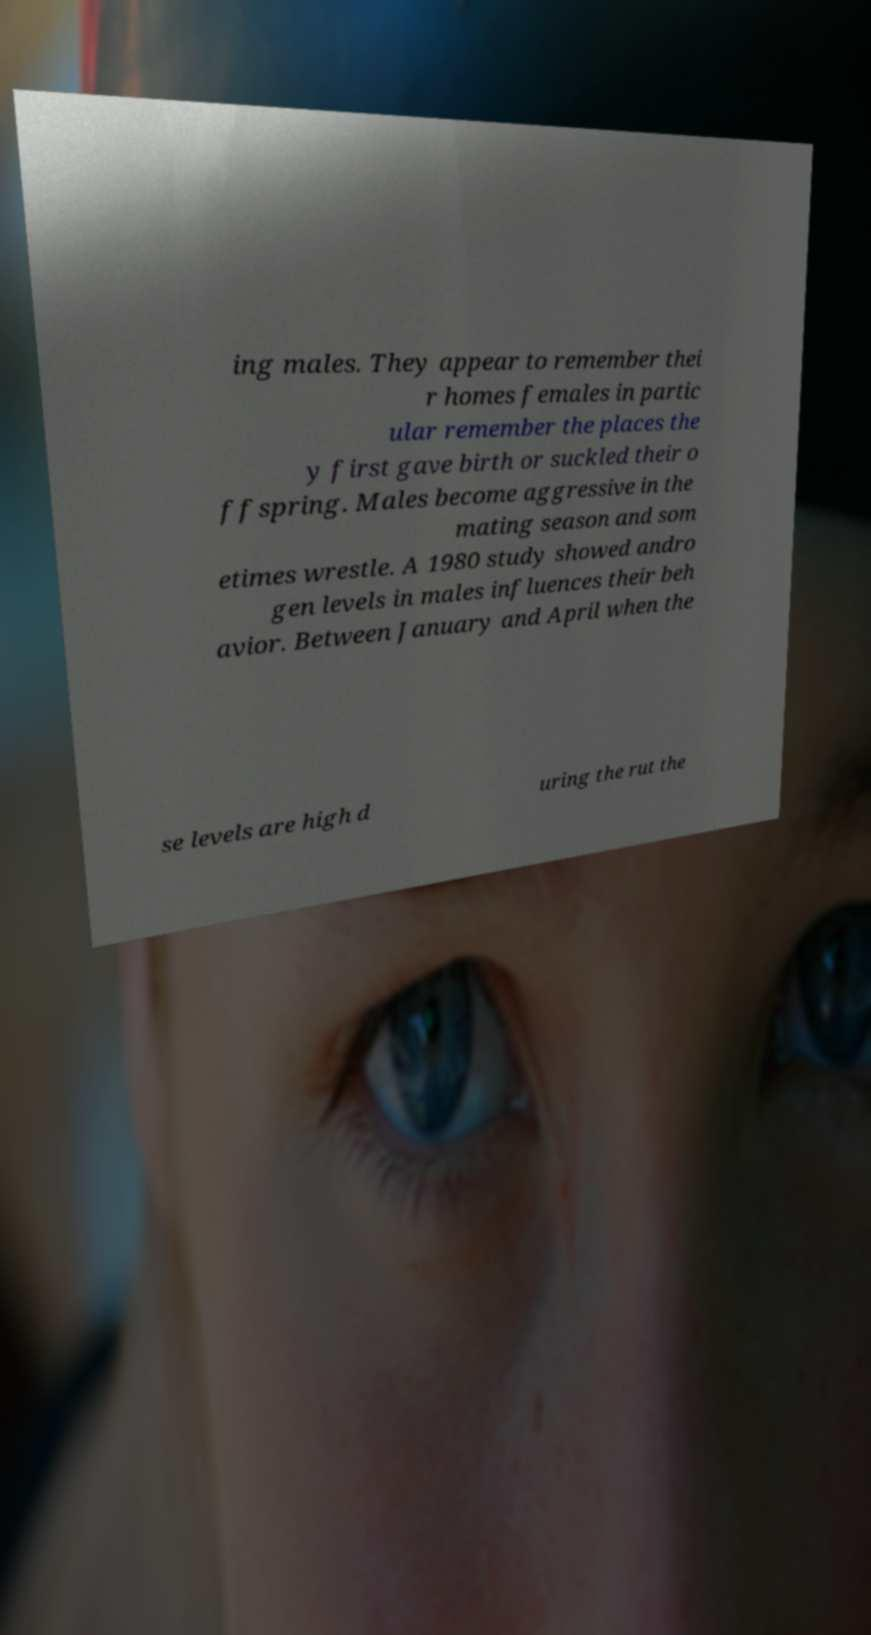I need the written content from this picture converted into text. Can you do that? ing males. They appear to remember thei r homes females in partic ular remember the places the y first gave birth or suckled their o ffspring. Males become aggressive in the mating season and som etimes wrestle. A 1980 study showed andro gen levels in males influences their beh avior. Between January and April when the se levels are high d uring the rut the 